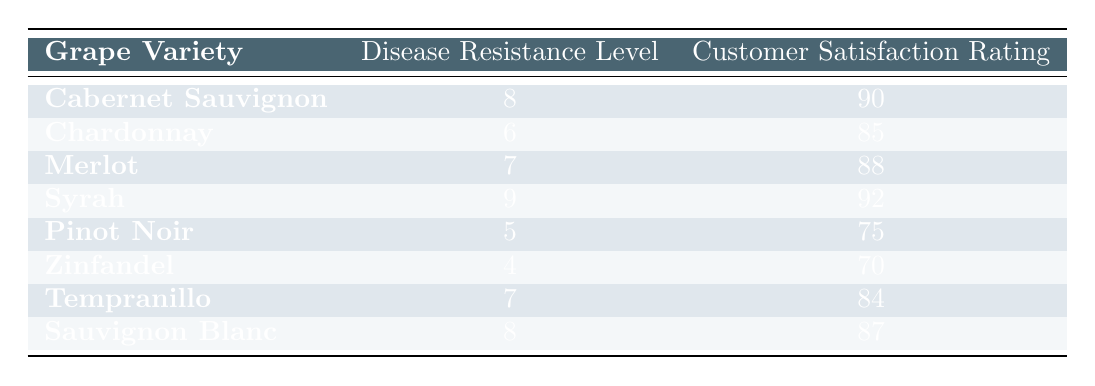What is the customer satisfaction rating of Syrah? The customer satisfaction rating of Syrah is listed directly in the table under the respective column where the grape variety is mentioned. It shows 92.
Answer: 92 Which grape variety has the highest disease resistance level? By looking at the disease resistance levels in the table, Syrah shows a level of 9, which is higher than all other varieties.
Answer: Syrah What is the average customer satisfaction rating for all grape varieties? To find the average, add the customer satisfaction ratings (90 + 85 + 88 + 92 + 75 + 70 + 84 + 87 = 691) and divide by the number of varieties (8). 691 / 8 = 86.375, rounded to 86.4.
Answer: 86.4 Is Zinfandel rated higher than Cabernet Sauvignon in customer satisfaction? By checking the customer satisfaction ratings, Zinfandel has a rating of 70, while Cabernet Sauvignon has a rating of 90. Since 70 is less than 90, the answer is no.
Answer: No What is the difference in disease resistance level between Pinot Noir and Cabernet Sauvignon? The disease resistance level for Pinot Noir is 5, while for Cabernet Sauvignon it is 8. The difference can be found by subtracting these values (8 - 5 = 3).
Answer: 3 Is Sauvignon Blanc's customer satisfaction rating above 85? Checking the table reveals that Sauvignon Blanc has a customer satisfaction rating of 87, which is indeed above 85. Therefore, the statement is true.
Answer: Yes Which grape variety has the lowest customer satisfaction rating? The table provides customer satisfaction ratings for all varieties. Zinfandel has the lowest rating at 70 when compared to the others.
Answer: Zinfandel If we consider grape varieties with a disease resistance level of 7 or higher, what is their average customer satisfaction rating? The varieties with a disease resistance level of 7 or higher are Cabernet Sauvignon (90), Merlot (88), Syrah (92), and Sauvignon Blanc (87). Adding these ratings gives (90 + 88 + 92 + 87 = 357), and then divide by the number of varieties (4), which gives 357 / 4 = 89.25. So, the average rating is 89.25.
Answer: 89.25 